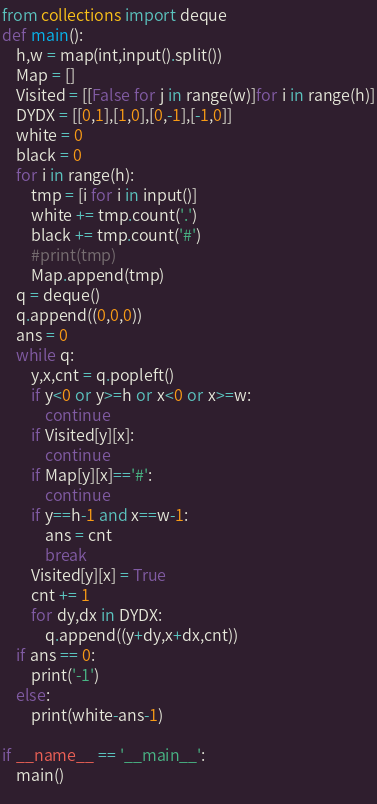Convert code to text. <code><loc_0><loc_0><loc_500><loc_500><_Python_>from collections import deque
def main():
    h,w = map(int,input().split())
    Map = []
    Visited = [[False for j in range(w)]for i in range(h)]
    DYDX = [[0,1],[1,0],[0,-1],[-1,0]]
    white = 0
    black = 0
    for i in range(h):
        tmp = [i for i in input()]
        white += tmp.count('.')
        black += tmp.count('#')
        #print(tmp)
        Map.append(tmp)
    q = deque()
    q.append((0,0,0))
    ans = 0
    while q:
        y,x,cnt = q.popleft()
        if y<0 or y>=h or x<0 or x>=w:
            continue
        if Visited[y][x]:
            continue
        if Map[y][x]=='#':
            continue
        if y==h-1 and x==w-1:
            ans = cnt
            break
        Visited[y][x] = True
        cnt += 1
        for dy,dx in DYDX:
            q.append((y+dy,x+dx,cnt))
    if ans == 0:
        print('-1')
    else:
        print(white-ans-1) 

if __name__ == '__main__':
    main()
    </code> 